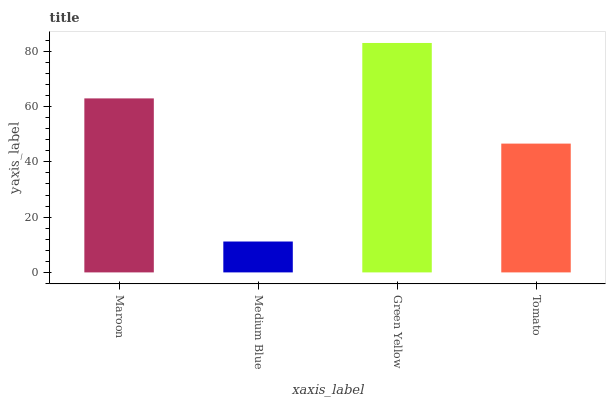Is Medium Blue the minimum?
Answer yes or no. Yes. Is Green Yellow the maximum?
Answer yes or no. Yes. Is Green Yellow the minimum?
Answer yes or no. No. Is Medium Blue the maximum?
Answer yes or no. No. Is Green Yellow greater than Medium Blue?
Answer yes or no. Yes. Is Medium Blue less than Green Yellow?
Answer yes or no. Yes. Is Medium Blue greater than Green Yellow?
Answer yes or no. No. Is Green Yellow less than Medium Blue?
Answer yes or no. No. Is Maroon the high median?
Answer yes or no. Yes. Is Tomato the low median?
Answer yes or no. Yes. Is Tomato the high median?
Answer yes or no. No. Is Maroon the low median?
Answer yes or no. No. 